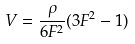<formula> <loc_0><loc_0><loc_500><loc_500>V = \frac { \rho } { 6 F ^ { 2 } } ( 3 F ^ { 2 } - 1 )</formula> 